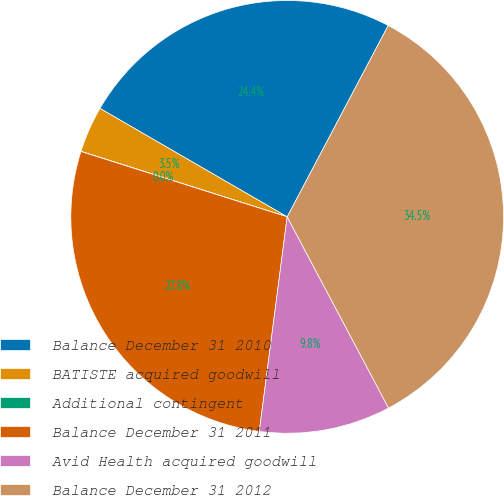Convert chart. <chart><loc_0><loc_0><loc_500><loc_500><pie_chart><fcel>Balance December 31 2010<fcel>BATISTE acquired goodwill<fcel>Additional contingent<fcel>Balance December 31 2011<fcel>Avid Health acquired goodwill<fcel>Balance December 31 2012<nl><fcel>24.38%<fcel>3.46%<fcel>0.01%<fcel>27.83%<fcel>9.82%<fcel>34.51%<nl></chart> 